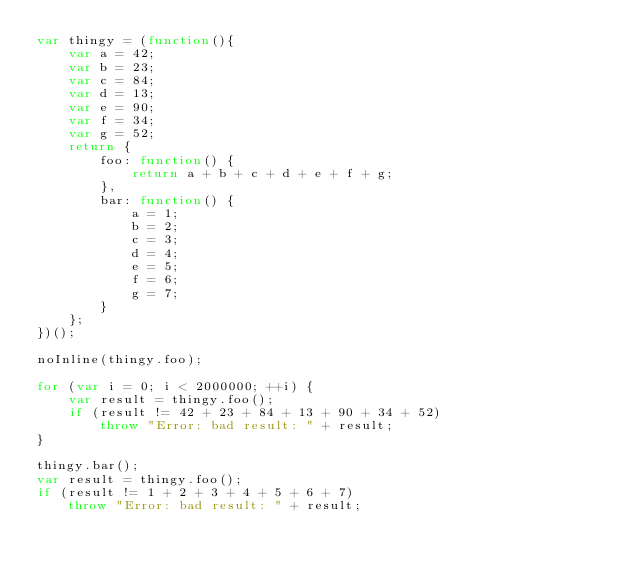<code> <loc_0><loc_0><loc_500><loc_500><_JavaScript_>var thingy = (function(){
    var a = 42;
    var b = 23;
    var c = 84;
    var d = 13;
    var e = 90;
    var f = 34;
    var g = 52;
    return {
        foo: function() {
            return a + b + c + d + e + f + g;
        },
        bar: function() {
            a = 1;
            b = 2;
            c = 3;
            d = 4;
            e = 5;
            f = 6;
            g = 7;
        }
    };
})();

noInline(thingy.foo);

for (var i = 0; i < 2000000; ++i) {
    var result = thingy.foo();
    if (result != 42 + 23 + 84 + 13 + 90 + 34 + 52)
        throw "Error: bad result: " + result;
}

thingy.bar();
var result = thingy.foo();
if (result != 1 + 2 + 3 + 4 + 5 + 6 + 7)
    throw "Error: bad result: " + result;
</code> 